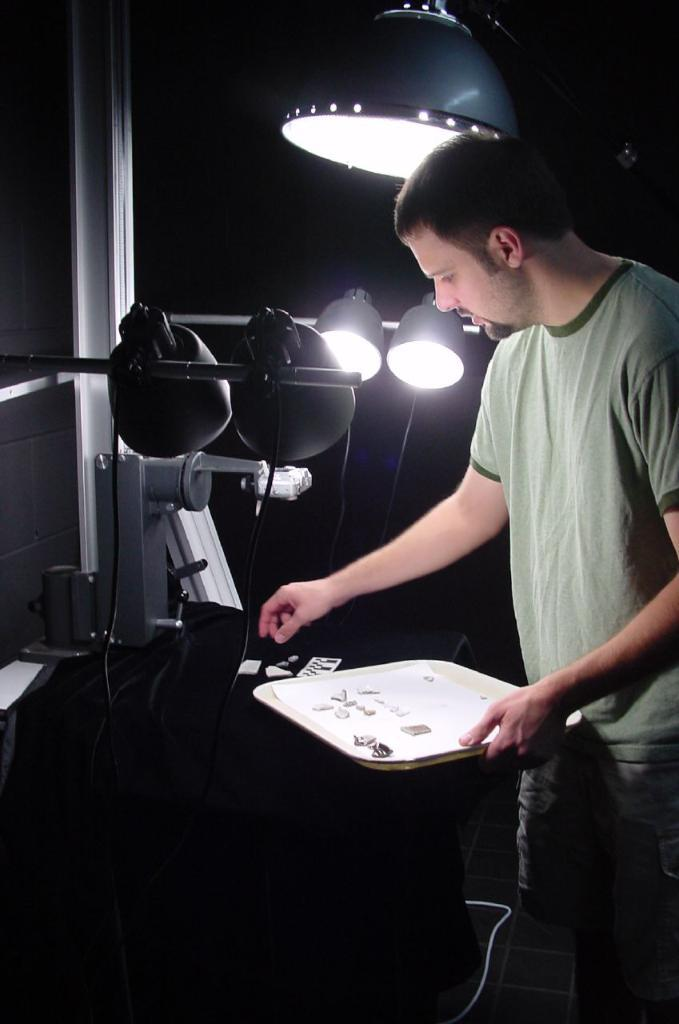What is the person in the image holding? There is a person holding an object in the image. What can be seen on the wooden object in the image? There are objects placed on a wooden object in the image. What type of lighting is present in the image? There are lamps in the image. What type of amusement can be seen in the image? There is no amusement present in the image; it features a person holding an object, objects on a wooden object, and lamps. Is there a scarf visible on the person in the image? There is no mention of a scarf in the provided facts, so it cannot be determined if one is visible in the image. 